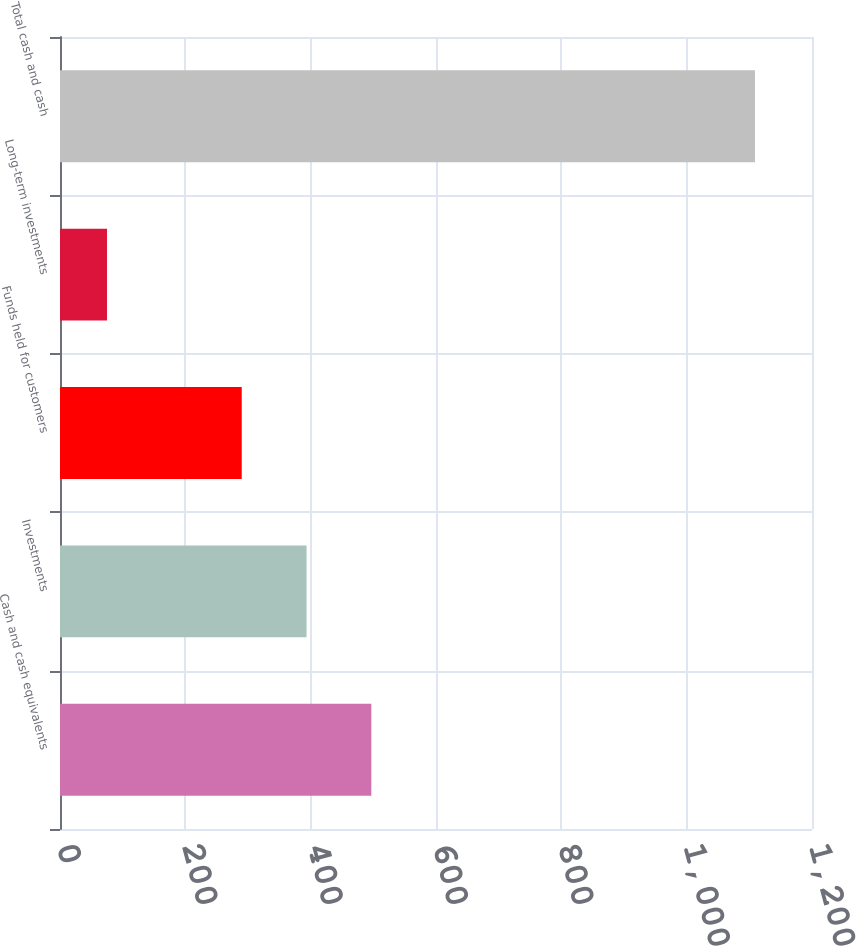Convert chart. <chart><loc_0><loc_0><loc_500><loc_500><bar_chart><fcel>Cash and cash equivalents<fcel>Investments<fcel>Funds held for customers<fcel>Long-term investments<fcel>Total cash and cash<nl><fcel>496.8<fcel>393.4<fcel>290<fcel>75<fcel>1109<nl></chart> 